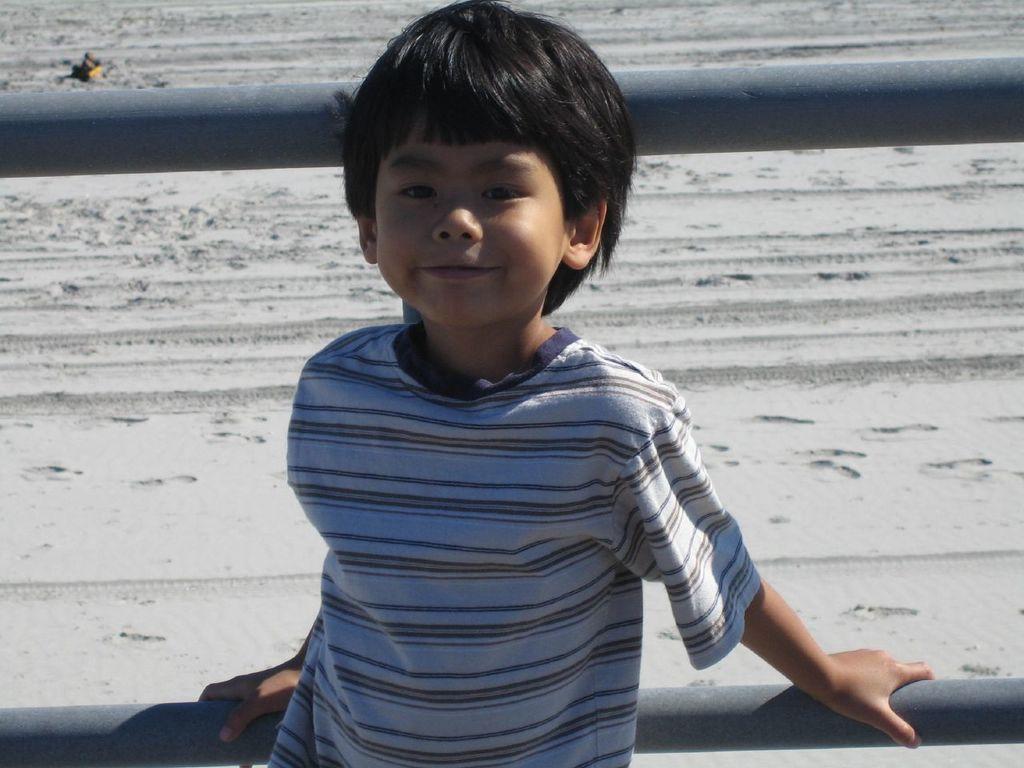Please provide a concise description of this image. Here in this picture we can see a child standing over a place and smiling and behind him we can see a railing present and we can see the ground is covered with sand. 